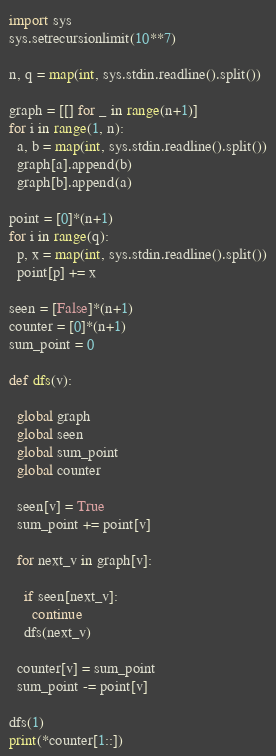<code> <loc_0><loc_0><loc_500><loc_500><_Python_>import sys
sys.setrecursionlimit(10**7)

n, q = map(int, sys.stdin.readline().split())

graph = [[] for _ in range(n+1)] 
for i in range(1, n):
  a, b = map(int, sys.stdin.readline().split())
  graph[a].append(b)
  graph[b].append(a)

point = [0]*(n+1)
for i in range(q):
  p, x = map(int, sys.stdin.readline().split())
  point[p] += x

seen = [False]*(n+1)
counter = [0]*(n+1)
sum_point = 0

def dfs(v):
  
  global graph
  global seen
  global sum_point
  global counter
  
  seen[v] = True
  sum_point += point[v]
  
  for next_v in graph[v]:
    
    if seen[next_v]: 
      continue
    dfs(next_v)
  
  counter[v] = sum_point
  sum_point -= point[v]

dfs(1)
print(*counter[1::])</code> 